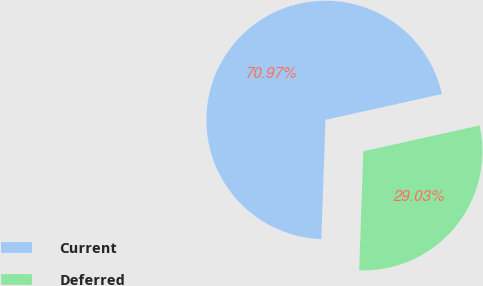Convert chart. <chart><loc_0><loc_0><loc_500><loc_500><pie_chart><fcel>Current<fcel>Deferred<nl><fcel>70.97%<fcel>29.03%<nl></chart> 